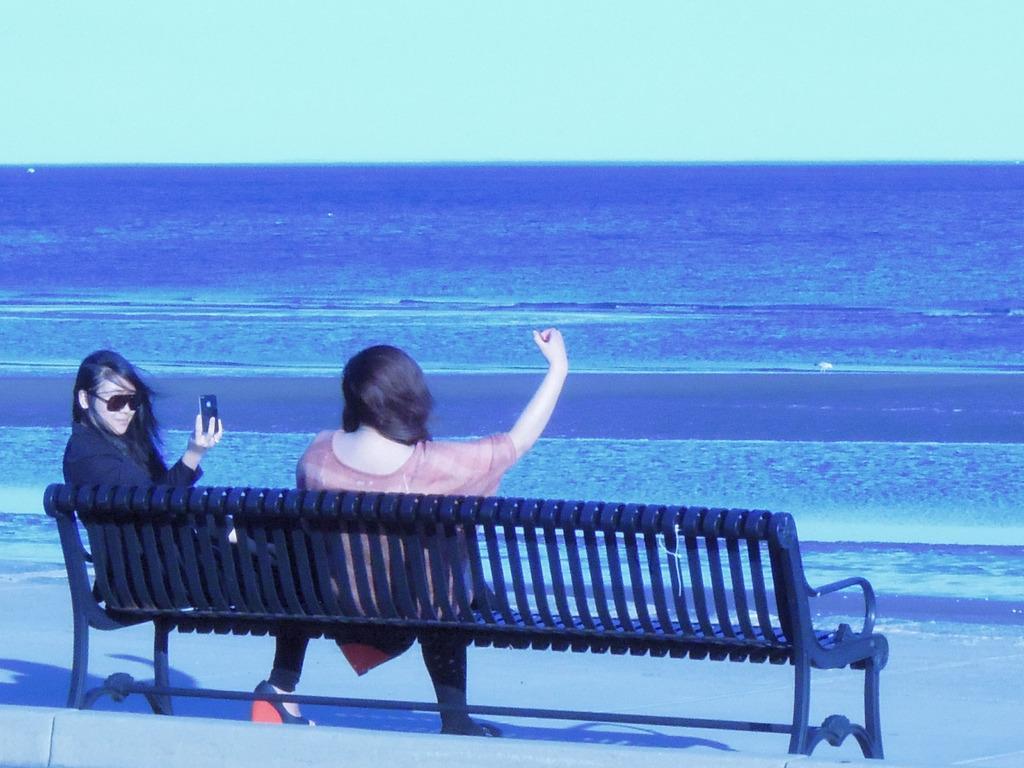Please provide a concise description of this image. In this image we can see women sitting on the bench and one of them is holding mobile phone in the hands. In the background we can see sea and sky. 